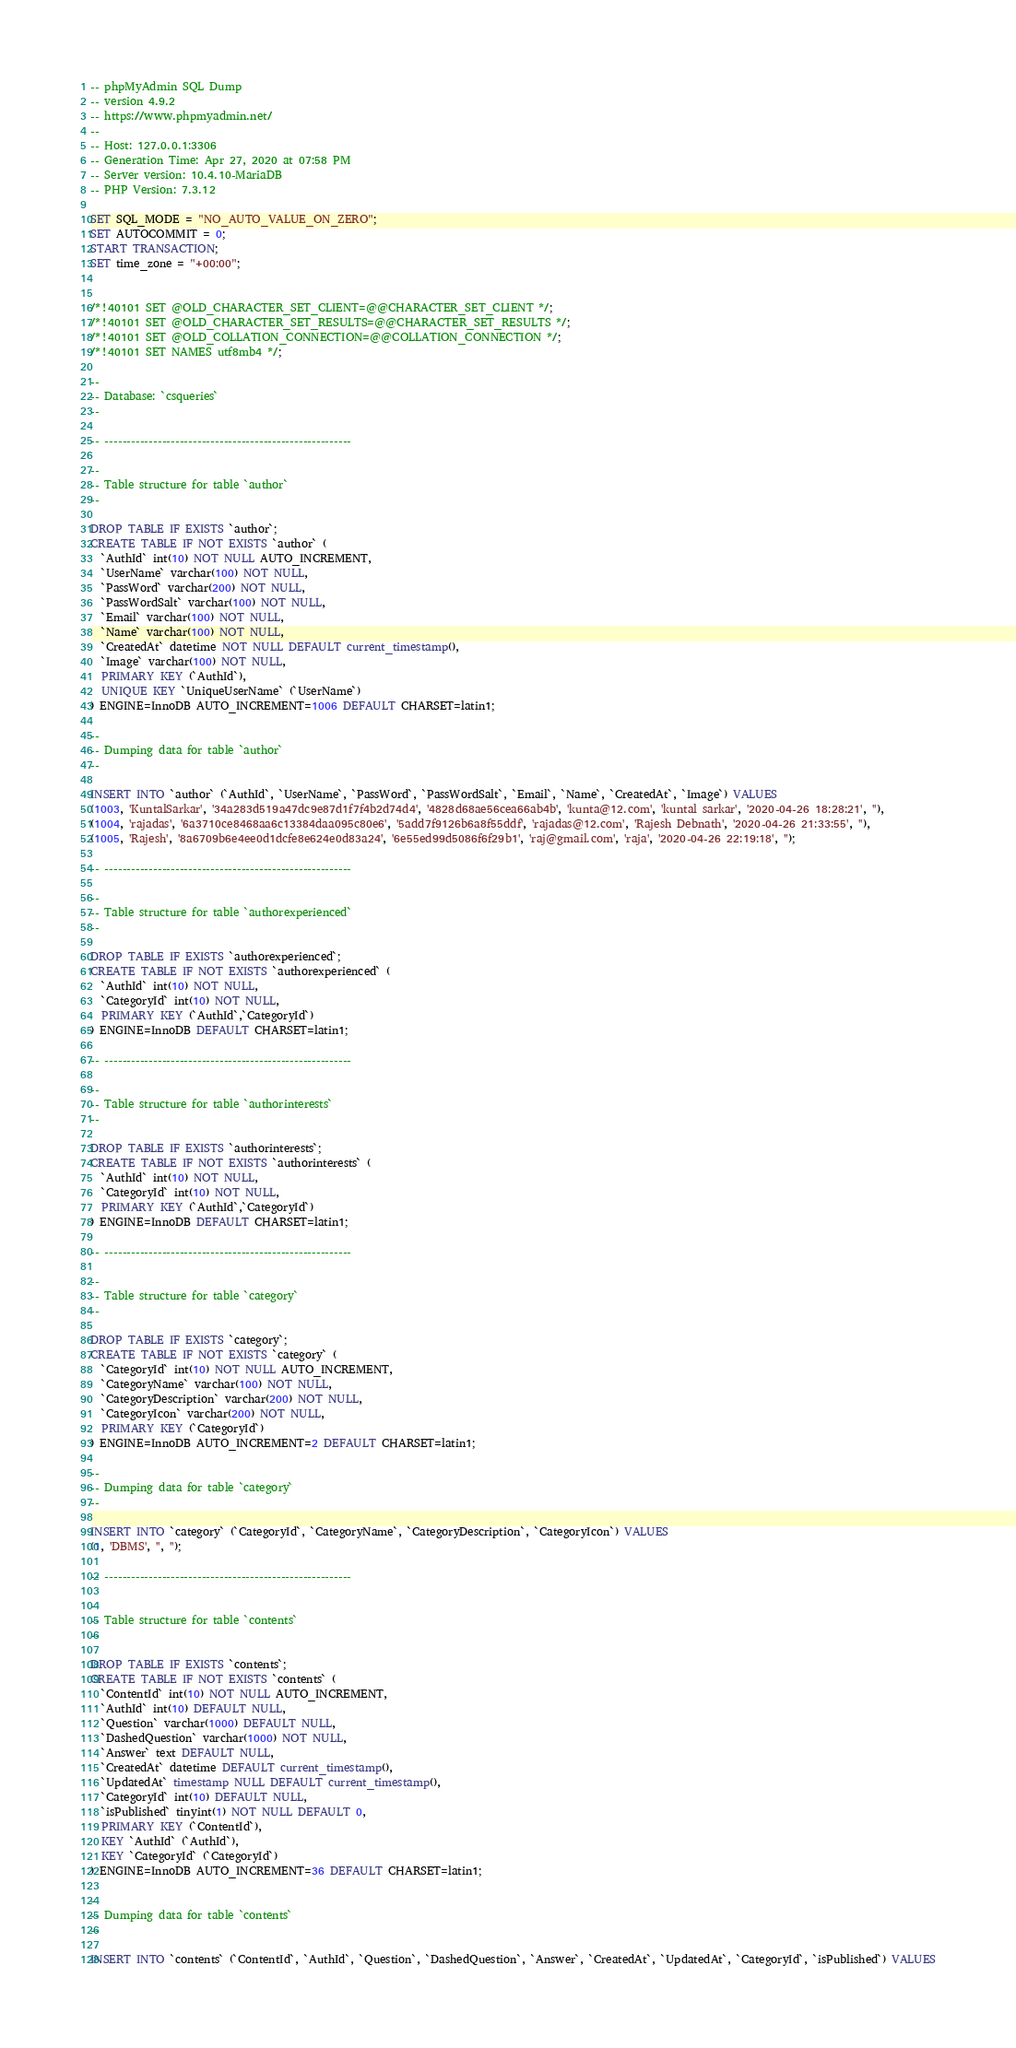Convert code to text. <code><loc_0><loc_0><loc_500><loc_500><_SQL_>-- phpMyAdmin SQL Dump
-- version 4.9.2
-- https://www.phpmyadmin.net/
--
-- Host: 127.0.0.1:3306
-- Generation Time: Apr 27, 2020 at 07:58 PM
-- Server version: 10.4.10-MariaDB
-- PHP Version: 7.3.12

SET SQL_MODE = "NO_AUTO_VALUE_ON_ZERO";
SET AUTOCOMMIT = 0;
START TRANSACTION;
SET time_zone = "+00:00";


/*!40101 SET @OLD_CHARACTER_SET_CLIENT=@@CHARACTER_SET_CLIENT */;
/*!40101 SET @OLD_CHARACTER_SET_RESULTS=@@CHARACTER_SET_RESULTS */;
/*!40101 SET @OLD_COLLATION_CONNECTION=@@COLLATION_CONNECTION */;
/*!40101 SET NAMES utf8mb4 */;

--
-- Database: `csqueries`
--

-- --------------------------------------------------------

--
-- Table structure for table `author`
--

DROP TABLE IF EXISTS `author`;
CREATE TABLE IF NOT EXISTS `author` (
  `AuthId` int(10) NOT NULL AUTO_INCREMENT,
  `UserName` varchar(100) NOT NULL,
  `PassWord` varchar(200) NOT NULL,
  `PassWordSalt` varchar(100) NOT NULL,
  `Email` varchar(100) NOT NULL,
  `Name` varchar(100) NOT NULL,
  `CreatedAt` datetime NOT NULL DEFAULT current_timestamp(),
  `Image` varchar(100) NOT NULL,
  PRIMARY KEY (`AuthId`),
  UNIQUE KEY `UniqueUserName` (`UserName`)
) ENGINE=InnoDB AUTO_INCREMENT=1006 DEFAULT CHARSET=latin1;

--
-- Dumping data for table `author`
--

INSERT INTO `author` (`AuthId`, `UserName`, `PassWord`, `PassWordSalt`, `Email`, `Name`, `CreatedAt`, `Image`) VALUES
(1003, 'KuntalSarkar', '34a283d519a47dc9e87d1f7f4b2d74d4', '4828d68ae56cea66ab4b', 'kunta@12.com', 'kuntal sarkar', '2020-04-26 18:28:21', ''),
(1004, 'rajadas', '6a3710ce8468aa6c13384daa095c80e6', '5add7f9126b6a8f55ddf', 'rajadas@12.com', 'Rajesh Debnath', '2020-04-26 21:33:55', ''),
(1005, 'Rajesh', '8a6709b6e4ee0d1dcfe8e624e0d83a24', '6e55ed99d5086f6f29b1', 'raj@gmail.com', 'raja', '2020-04-26 22:19:18', '');

-- --------------------------------------------------------

--
-- Table structure for table `authorexperienced`
--

DROP TABLE IF EXISTS `authorexperienced`;
CREATE TABLE IF NOT EXISTS `authorexperienced` (
  `AuthId` int(10) NOT NULL,
  `CategoryId` int(10) NOT NULL,
  PRIMARY KEY (`AuthId`,`CategoryId`)
) ENGINE=InnoDB DEFAULT CHARSET=latin1;

-- --------------------------------------------------------

--
-- Table structure for table `authorinterests`
--

DROP TABLE IF EXISTS `authorinterests`;
CREATE TABLE IF NOT EXISTS `authorinterests` (
  `AuthId` int(10) NOT NULL,
  `CategoryId` int(10) NOT NULL,
  PRIMARY KEY (`AuthId`,`CategoryId`)
) ENGINE=InnoDB DEFAULT CHARSET=latin1;

-- --------------------------------------------------------

--
-- Table structure for table `category`
--

DROP TABLE IF EXISTS `category`;
CREATE TABLE IF NOT EXISTS `category` (
  `CategoryId` int(10) NOT NULL AUTO_INCREMENT,
  `CategoryName` varchar(100) NOT NULL,
  `CategoryDescription` varchar(200) NOT NULL,
  `CategoryIcon` varchar(200) NOT NULL,
  PRIMARY KEY (`CategoryId`)
) ENGINE=InnoDB AUTO_INCREMENT=2 DEFAULT CHARSET=latin1;

--
-- Dumping data for table `category`
--

INSERT INTO `category` (`CategoryId`, `CategoryName`, `CategoryDescription`, `CategoryIcon`) VALUES
(1, 'DBMS', '', '');

-- --------------------------------------------------------

--
-- Table structure for table `contents`
--

DROP TABLE IF EXISTS `contents`;
CREATE TABLE IF NOT EXISTS `contents` (
  `ContentId` int(10) NOT NULL AUTO_INCREMENT,
  `AuthId` int(10) DEFAULT NULL,
  `Question` varchar(1000) DEFAULT NULL,
  `DashedQuestion` varchar(1000) NOT NULL,
  `Answer` text DEFAULT NULL,
  `CreatedAt` datetime DEFAULT current_timestamp(),
  `UpdatedAt` timestamp NULL DEFAULT current_timestamp(),
  `CategoryId` int(10) DEFAULT NULL,
  `isPublished` tinyint(1) NOT NULL DEFAULT 0,
  PRIMARY KEY (`ContentId`),
  KEY `AuthId` (`AuthId`),
  KEY `CategoryId` (`CategoryId`)
) ENGINE=InnoDB AUTO_INCREMENT=36 DEFAULT CHARSET=latin1;

--
-- Dumping data for table `contents`
--

INSERT INTO `contents` (`ContentId`, `AuthId`, `Question`, `DashedQuestion`, `Answer`, `CreatedAt`, `UpdatedAt`, `CategoryId`, `isPublished`) VALUES</code> 